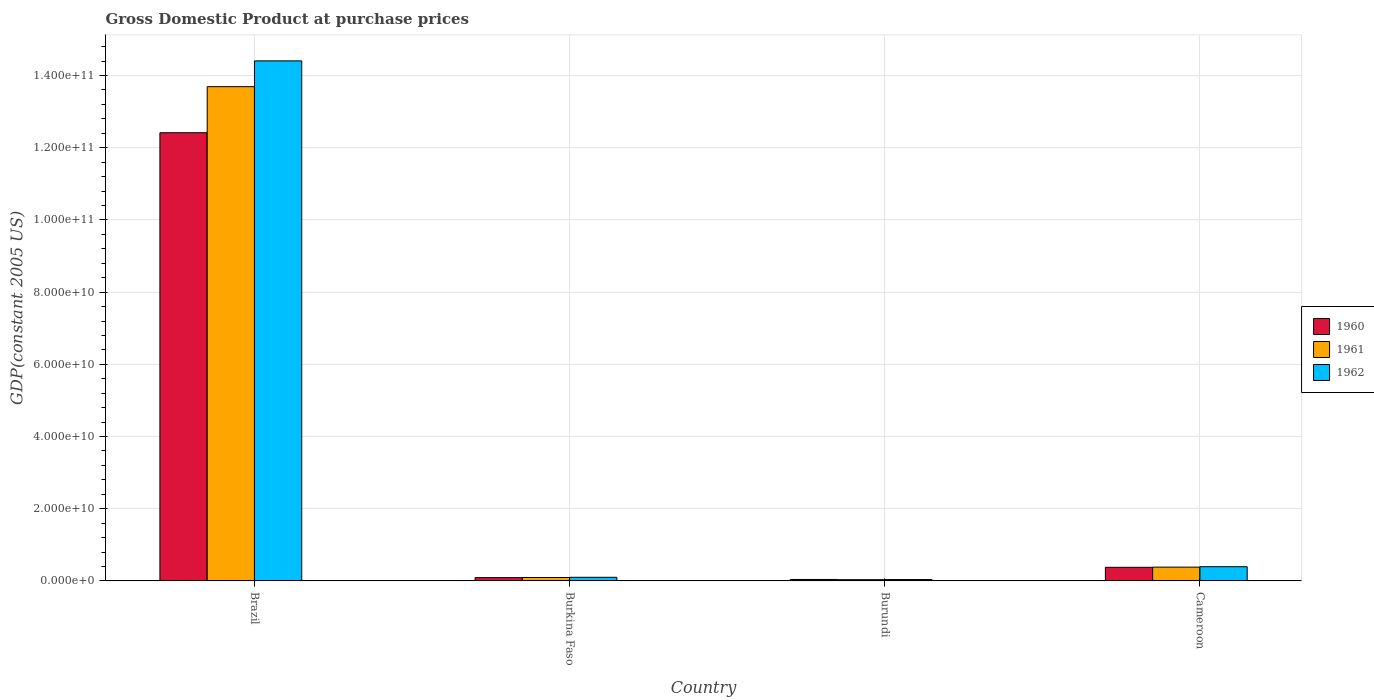Are the number of bars per tick equal to the number of legend labels?
Keep it short and to the point. Yes. What is the label of the 2nd group of bars from the left?
Your answer should be compact. Burkina Faso. What is the GDP at purchase prices in 1961 in Cameroon?
Keep it short and to the point. 3.82e+09. Across all countries, what is the maximum GDP at purchase prices in 1962?
Ensure brevity in your answer.  1.44e+11. Across all countries, what is the minimum GDP at purchase prices in 1962?
Provide a succinct answer. 3.85e+08. In which country was the GDP at purchase prices in 1961 minimum?
Offer a very short reply. Burundi. What is the total GDP at purchase prices in 1960 in the graph?
Ensure brevity in your answer.  1.29e+11. What is the difference between the GDP at purchase prices in 1961 in Brazil and that in Burundi?
Your answer should be very brief. 1.37e+11. What is the difference between the GDP at purchase prices in 1962 in Brazil and the GDP at purchase prices in 1961 in Burkina Faso?
Your answer should be compact. 1.43e+11. What is the average GDP at purchase prices in 1960 per country?
Keep it short and to the point. 3.23e+1. What is the difference between the GDP at purchase prices of/in 1960 and GDP at purchase prices of/in 1962 in Burkina Faso?
Provide a short and direct response. -9.56e+07. In how many countries, is the GDP at purchase prices in 1962 greater than 88000000000 US$?
Provide a succinct answer. 1. What is the ratio of the GDP at purchase prices in 1961 in Burkina Faso to that in Burundi?
Your response must be concise. 2.7. Is the difference between the GDP at purchase prices in 1960 in Brazil and Cameroon greater than the difference between the GDP at purchase prices in 1962 in Brazil and Cameroon?
Ensure brevity in your answer.  No. What is the difference between the highest and the second highest GDP at purchase prices in 1960?
Your answer should be very brief. -1.20e+11. What is the difference between the highest and the lowest GDP at purchase prices in 1962?
Offer a very short reply. 1.44e+11. Is the sum of the GDP at purchase prices in 1960 in Burkina Faso and Cameroon greater than the maximum GDP at purchase prices in 1961 across all countries?
Your answer should be very brief. No. Is it the case that in every country, the sum of the GDP at purchase prices in 1962 and GDP at purchase prices in 1960 is greater than the GDP at purchase prices in 1961?
Provide a short and direct response. Yes. How many bars are there?
Ensure brevity in your answer.  12. How many countries are there in the graph?
Offer a terse response. 4. What is the difference between two consecutive major ticks on the Y-axis?
Ensure brevity in your answer.  2.00e+1. Does the graph contain any zero values?
Provide a short and direct response. No. Does the graph contain grids?
Your response must be concise. Yes. How many legend labels are there?
Your answer should be compact. 3. How are the legend labels stacked?
Make the answer very short. Vertical. What is the title of the graph?
Give a very brief answer. Gross Domestic Product at purchase prices. Does "1965" appear as one of the legend labels in the graph?
Make the answer very short. No. What is the label or title of the Y-axis?
Provide a succinct answer. GDP(constant 2005 US). What is the GDP(constant 2005 US) in 1960 in Brazil?
Offer a very short reply. 1.24e+11. What is the GDP(constant 2005 US) of 1961 in Brazil?
Make the answer very short. 1.37e+11. What is the GDP(constant 2005 US) of 1962 in Brazil?
Ensure brevity in your answer.  1.44e+11. What is the GDP(constant 2005 US) in 1960 in Burkina Faso?
Your answer should be very brief. 9.17e+08. What is the GDP(constant 2005 US) of 1961 in Burkina Faso?
Keep it short and to the point. 9.54e+08. What is the GDP(constant 2005 US) of 1962 in Burkina Faso?
Make the answer very short. 1.01e+09. What is the GDP(constant 2005 US) of 1960 in Burundi?
Offer a very short reply. 4.10e+08. What is the GDP(constant 2005 US) in 1961 in Burundi?
Ensure brevity in your answer.  3.53e+08. What is the GDP(constant 2005 US) of 1962 in Burundi?
Provide a short and direct response. 3.85e+08. What is the GDP(constant 2005 US) in 1960 in Cameroon?
Offer a very short reply. 3.78e+09. What is the GDP(constant 2005 US) in 1961 in Cameroon?
Make the answer very short. 3.82e+09. What is the GDP(constant 2005 US) in 1962 in Cameroon?
Offer a terse response. 3.94e+09. Across all countries, what is the maximum GDP(constant 2005 US) of 1960?
Give a very brief answer. 1.24e+11. Across all countries, what is the maximum GDP(constant 2005 US) of 1961?
Your response must be concise. 1.37e+11. Across all countries, what is the maximum GDP(constant 2005 US) of 1962?
Offer a very short reply. 1.44e+11. Across all countries, what is the minimum GDP(constant 2005 US) of 1960?
Make the answer very short. 4.10e+08. Across all countries, what is the minimum GDP(constant 2005 US) of 1961?
Ensure brevity in your answer.  3.53e+08. Across all countries, what is the minimum GDP(constant 2005 US) of 1962?
Give a very brief answer. 3.85e+08. What is the total GDP(constant 2005 US) of 1960 in the graph?
Offer a very short reply. 1.29e+11. What is the total GDP(constant 2005 US) of 1961 in the graph?
Offer a very short reply. 1.42e+11. What is the total GDP(constant 2005 US) in 1962 in the graph?
Your response must be concise. 1.49e+11. What is the difference between the GDP(constant 2005 US) of 1960 in Brazil and that in Burkina Faso?
Provide a short and direct response. 1.23e+11. What is the difference between the GDP(constant 2005 US) of 1961 in Brazil and that in Burkina Faso?
Your answer should be very brief. 1.36e+11. What is the difference between the GDP(constant 2005 US) in 1962 in Brazil and that in Burkina Faso?
Provide a succinct answer. 1.43e+11. What is the difference between the GDP(constant 2005 US) in 1960 in Brazil and that in Burundi?
Your answer should be very brief. 1.24e+11. What is the difference between the GDP(constant 2005 US) of 1961 in Brazil and that in Burundi?
Offer a terse response. 1.37e+11. What is the difference between the GDP(constant 2005 US) of 1962 in Brazil and that in Burundi?
Make the answer very short. 1.44e+11. What is the difference between the GDP(constant 2005 US) of 1960 in Brazil and that in Cameroon?
Keep it short and to the point. 1.20e+11. What is the difference between the GDP(constant 2005 US) of 1961 in Brazil and that in Cameroon?
Provide a succinct answer. 1.33e+11. What is the difference between the GDP(constant 2005 US) in 1962 in Brazil and that in Cameroon?
Your response must be concise. 1.40e+11. What is the difference between the GDP(constant 2005 US) of 1960 in Burkina Faso and that in Burundi?
Ensure brevity in your answer.  5.07e+08. What is the difference between the GDP(constant 2005 US) in 1961 in Burkina Faso and that in Burundi?
Offer a terse response. 6.01e+08. What is the difference between the GDP(constant 2005 US) of 1962 in Burkina Faso and that in Burundi?
Offer a terse response. 6.27e+08. What is the difference between the GDP(constant 2005 US) in 1960 in Burkina Faso and that in Cameroon?
Keep it short and to the point. -2.86e+09. What is the difference between the GDP(constant 2005 US) of 1961 in Burkina Faso and that in Cameroon?
Provide a succinct answer. -2.87e+09. What is the difference between the GDP(constant 2005 US) of 1962 in Burkina Faso and that in Cameroon?
Provide a short and direct response. -2.93e+09. What is the difference between the GDP(constant 2005 US) in 1960 in Burundi and that in Cameroon?
Provide a succinct answer. -3.37e+09. What is the difference between the GDP(constant 2005 US) of 1961 in Burundi and that in Cameroon?
Offer a terse response. -3.47e+09. What is the difference between the GDP(constant 2005 US) in 1962 in Burundi and that in Cameroon?
Offer a very short reply. -3.55e+09. What is the difference between the GDP(constant 2005 US) of 1960 in Brazil and the GDP(constant 2005 US) of 1961 in Burkina Faso?
Your answer should be very brief. 1.23e+11. What is the difference between the GDP(constant 2005 US) in 1960 in Brazil and the GDP(constant 2005 US) in 1962 in Burkina Faso?
Offer a very short reply. 1.23e+11. What is the difference between the GDP(constant 2005 US) in 1961 in Brazil and the GDP(constant 2005 US) in 1962 in Burkina Faso?
Your answer should be very brief. 1.36e+11. What is the difference between the GDP(constant 2005 US) of 1960 in Brazil and the GDP(constant 2005 US) of 1961 in Burundi?
Offer a terse response. 1.24e+11. What is the difference between the GDP(constant 2005 US) of 1960 in Brazil and the GDP(constant 2005 US) of 1962 in Burundi?
Offer a very short reply. 1.24e+11. What is the difference between the GDP(constant 2005 US) of 1961 in Brazil and the GDP(constant 2005 US) of 1962 in Burundi?
Your answer should be very brief. 1.37e+11. What is the difference between the GDP(constant 2005 US) of 1960 in Brazil and the GDP(constant 2005 US) of 1961 in Cameroon?
Keep it short and to the point. 1.20e+11. What is the difference between the GDP(constant 2005 US) in 1960 in Brazil and the GDP(constant 2005 US) in 1962 in Cameroon?
Offer a very short reply. 1.20e+11. What is the difference between the GDP(constant 2005 US) of 1961 in Brazil and the GDP(constant 2005 US) of 1962 in Cameroon?
Provide a short and direct response. 1.33e+11. What is the difference between the GDP(constant 2005 US) of 1960 in Burkina Faso and the GDP(constant 2005 US) of 1961 in Burundi?
Your answer should be very brief. 5.64e+08. What is the difference between the GDP(constant 2005 US) of 1960 in Burkina Faso and the GDP(constant 2005 US) of 1962 in Burundi?
Your answer should be compact. 5.32e+08. What is the difference between the GDP(constant 2005 US) in 1961 in Burkina Faso and the GDP(constant 2005 US) in 1962 in Burundi?
Your response must be concise. 5.69e+08. What is the difference between the GDP(constant 2005 US) of 1960 in Burkina Faso and the GDP(constant 2005 US) of 1961 in Cameroon?
Keep it short and to the point. -2.91e+09. What is the difference between the GDP(constant 2005 US) of 1960 in Burkina Faso and the GDP(constant 2005 US) of 1962 in Cameroon?
Your answer should be very brief. -3.02e+09. What is the difference between the GDP(constant 2005 US) in 1961 in Burkina Faso and the GDP(constant 2005 US) in 1962 in Cameroon?
Offer a terse response. -2.99e+09. What is the difference between the GDP(constant 2005 US) in 1960 in Burundi and the GDP(constant 2005 US) in 1961 in Cameroon?
Your answer should be compact. -3.41e+09. What is the difference between the GDP(constant 2005 US) of 1960 in Burundi and the GDP(constant 2005 US) of 1962 in Cameroon?
Your answer should be compact. -3.53e+09. What is the difference between the GDP(constant 2005 US) in 1961 in Burundi and the GDP(constant 2005 US) in 1962 in Cameroon?
Keep it short and to the point. -3.59e+09. What is the average GDP(constant 2005 US) in 1960 per country?
Your answer should be very brief. 3.23e+1. What is the average GDP(constant 2005 US) in 1961 per country?
Make the answer very short. 3.55e+1. What is the average GDP(constant 2005 US) of 1962 per country?
Your response must be concise. 3.74e+1. What is the difference between the GDP(constant 2005 US) in 1960 and GDP(constant 2005 US) in 1961 in Brazil?
Provide a short and direct response. -1.28e+1. What is the difference between the GDP(constant 2005 US) in 1960 and GDP(constant 2005 US) in 1962 in Brazil?
Your answer should be compact. -1.99e+1. What is the difference between the GDP(constant 2005 US) of 1961 and GDP(constant 2005 US) of 1962 in Brazil?
Your answer should be compact. -7.14e+09. What is the difference between the GDP(constant 2005 US) in 1960 and GDP(constant 2005 US) in 1961 in Burkina Faso?
Give a very brief answer. -3.71e+07. What is the difference between the GDP(constant 2005 US) of 1960 and GDP(constant 2005 US) of 1962 in Burkina Faso?
Your answer should be very brief. -9.56e+07. What is the difference between the GDP(constant 2005 US) of 1961 and GDP(constant 2005 US) of 1962 in Burkina Faso?
Your response must be concise. -5.85e+07. What is the difference between the GDP(constant 2005 US) of 1960 and GDP(constant 2005 US) of 1961 in Burundi?
Provide a short and direct response. 5.63e+07. What is the difference between the GDP(constant 2005 US) of 1960 and GDP(constant 2005 US) of 1962 in Burundi?
Your response must be concise. 2.43e+07. What is the difference between the GDP(constant 2005 US) of 1961 and GDP(constant 2005 US) of 1962 in Burundi?
Keep it short and to the point. -3.20e+07. What is the difference between the GDP(constant 2005 US) of 1960 and GDP(constant 2005 US) of 1961 in Cameroon?
Provide a succinct answer. -4.47e+07. What is the difference between the GDP(constant 2005 US) in 1960 and GDP(constant 2005 US) in 1962 in Cameroon?
Your response must be concise. -1.61e+08. What is the difference between the GDP(constant 2005 US) in 1961 and GDP(constant 2005 US) in 1962 in Cameroon?
Provide a short and direct response. -1.16e+08. What is the ratio of the GDP(constant 2005 US) in 1960 in Brazil to that in Burkina Faso?
Make the answer very short. 135.4. What is the ratio of the GDP(constant 2005 US) of 1961 in Brazil to that in Burkina Faso?
Provide a short and direct response. 143.51. What is the ratio of the GDP(constant 2005 US) in 1962 in Brazil to that in Burkina Faso?
Provide a short and direct response. 142.28. What is the ratio of the GDP(constant 2005 US) in 1960 in Brazil to that in Burundi?
Ensure brevity in your answer.  303.09. What is the ratio of the GDP(constant 2005 US) of 1961 in Brazil to that in Burundi?
Offer a very short reply. 387.5. What is the ratio of the GDP(constant 2005 US) in 1962 in Brazil to that in Burundi?
Ensure brevity in your answer.  373.83. What is the ratio of the GDP(constant 2005 US) of 1960 in Brazil to that in Cameroon?
Ensure brevity in your answer.  32.86. What is the ratio of the GDP(constant 2005 US) in 1961 in Brazil to that in Cameroon?
Provide a short and direct response. 35.81. What is the ratio of the GDP(constant 2005 US) of 1962 in Brazil to that in Cameroon?
Your answer should be very brief. 36.57. What is the ratio of the GDP(constant 2005 US) of 1960 in Burkina Faso to that in Burundi?
Offer a very short reply. 2.24. What is the ratio of the GDP(constant 2005 US) in 1961 in Burkina Faso to that in Burundi?
Make the answer very short. 2.7. What is the ratio of the GDP(constant 2005 US) of 1962 in Burkina Faso to that in Burundi?
Your answer should be very brief. 2.63. What is the ratio of the GDP(constant 2005 US) of 1960 in Burkina Faso to that in Cameroon?
Your response must be concise. 0.24. What is the ratio of the GDP(constant 2005 US) of 1961 in Burkina Faso to that in Cameroon?
Your response must be concise. 0.25. What is the ratio of the GDP(constant 2005 US) of 1962 in Burkina Faso to that in Cameroon?
Offer a terse response. 0.26. What is the ratio of the GDP(constant 2005 US) of 1960 in Burundi to that in Cameroon?
Your response must be concise. 0.11. What is the ratio of the GDP(constant 2005 US) in 1961 in Burundi to that in Cameroon?
Provide a succinct answer. 0.09. What is the ratio of the GDP(constant 2005 US) of 1962 in Burundi to that in Cameroon?
Make the answer very short. 0.1. What is the difference between the highest and the second highest GDP(constant 2005 US) in 1960?
Give a very brief answer. 1.20e+11. What is the difference between the highest and the second highest GDP(constant 2005 US) in 1961?
Make the answer very short. 1.33e+11. What is the difference between the highest and the second highest GDP(constant 2005 US) in 1962?
Your answer should be very brief. 1.40e+11. What is the difference between the highest and the lowest GDP(constant 2005 US) in 1960?
Provide a short and direct response. 1.24e+11. What is the difference between the highest and the lowest GDP(constant 2005 US) in 1961?
Your response must be concise. 1.37e+11. What is the difference between the highest and the lowest GDP(constant 2005 US) in 1962?
Offer a very short reply. 1.44e+11. 